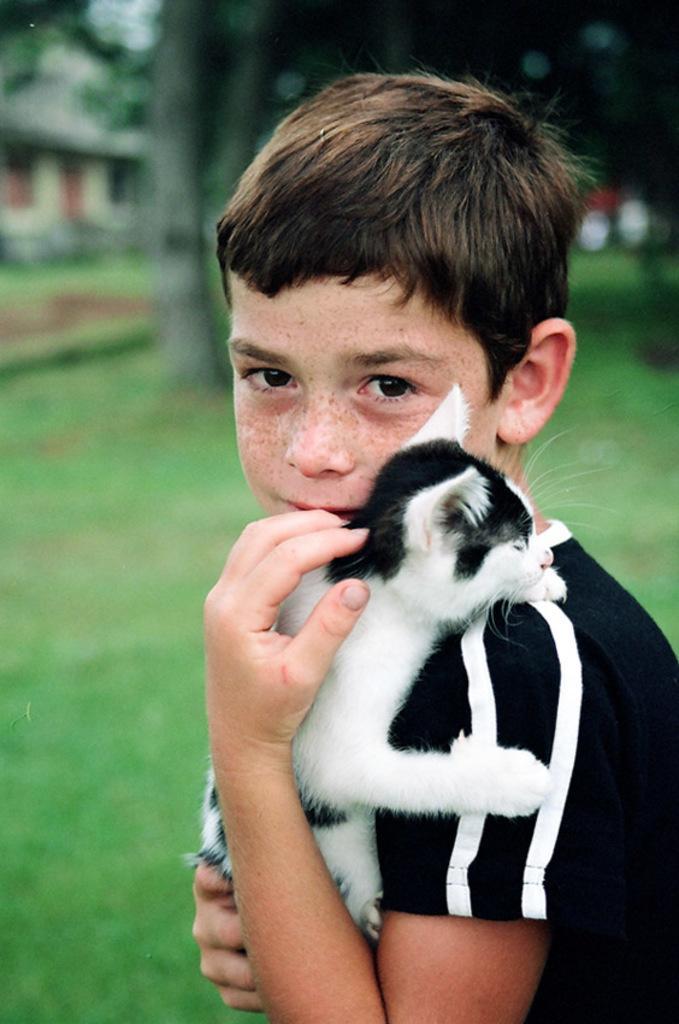Can you describe this image briefly? In this image we can see a boy holding a little cat in his arms. In the background there is a grass and few trees which is slightly blurred. 